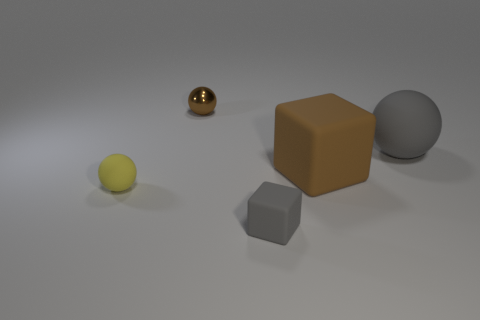Subtract all tiny rubber spheres. How many spheres are left? 2 Subtract all brown blocks. How many blocks are left? 1 Subtract 2 balls. How many balls are left? 1 Subtract all balls. How many objects are left? 2 Subtract all matte balls. Subtract all brown spheres. How many objects are left? 2 Add 5 tiny brown objects. How many tiny brown objects are left? 6 Add 5 small purple spheres. How many small purple spheres exist? 5 Add 1 large red rubber cubes. How many objects exist? 6 Subtract 0 blue cylinders. How many objects are left? 5 Subtract all red spheres. Subtract all yellow cylinders. How many spheres are left? 3 